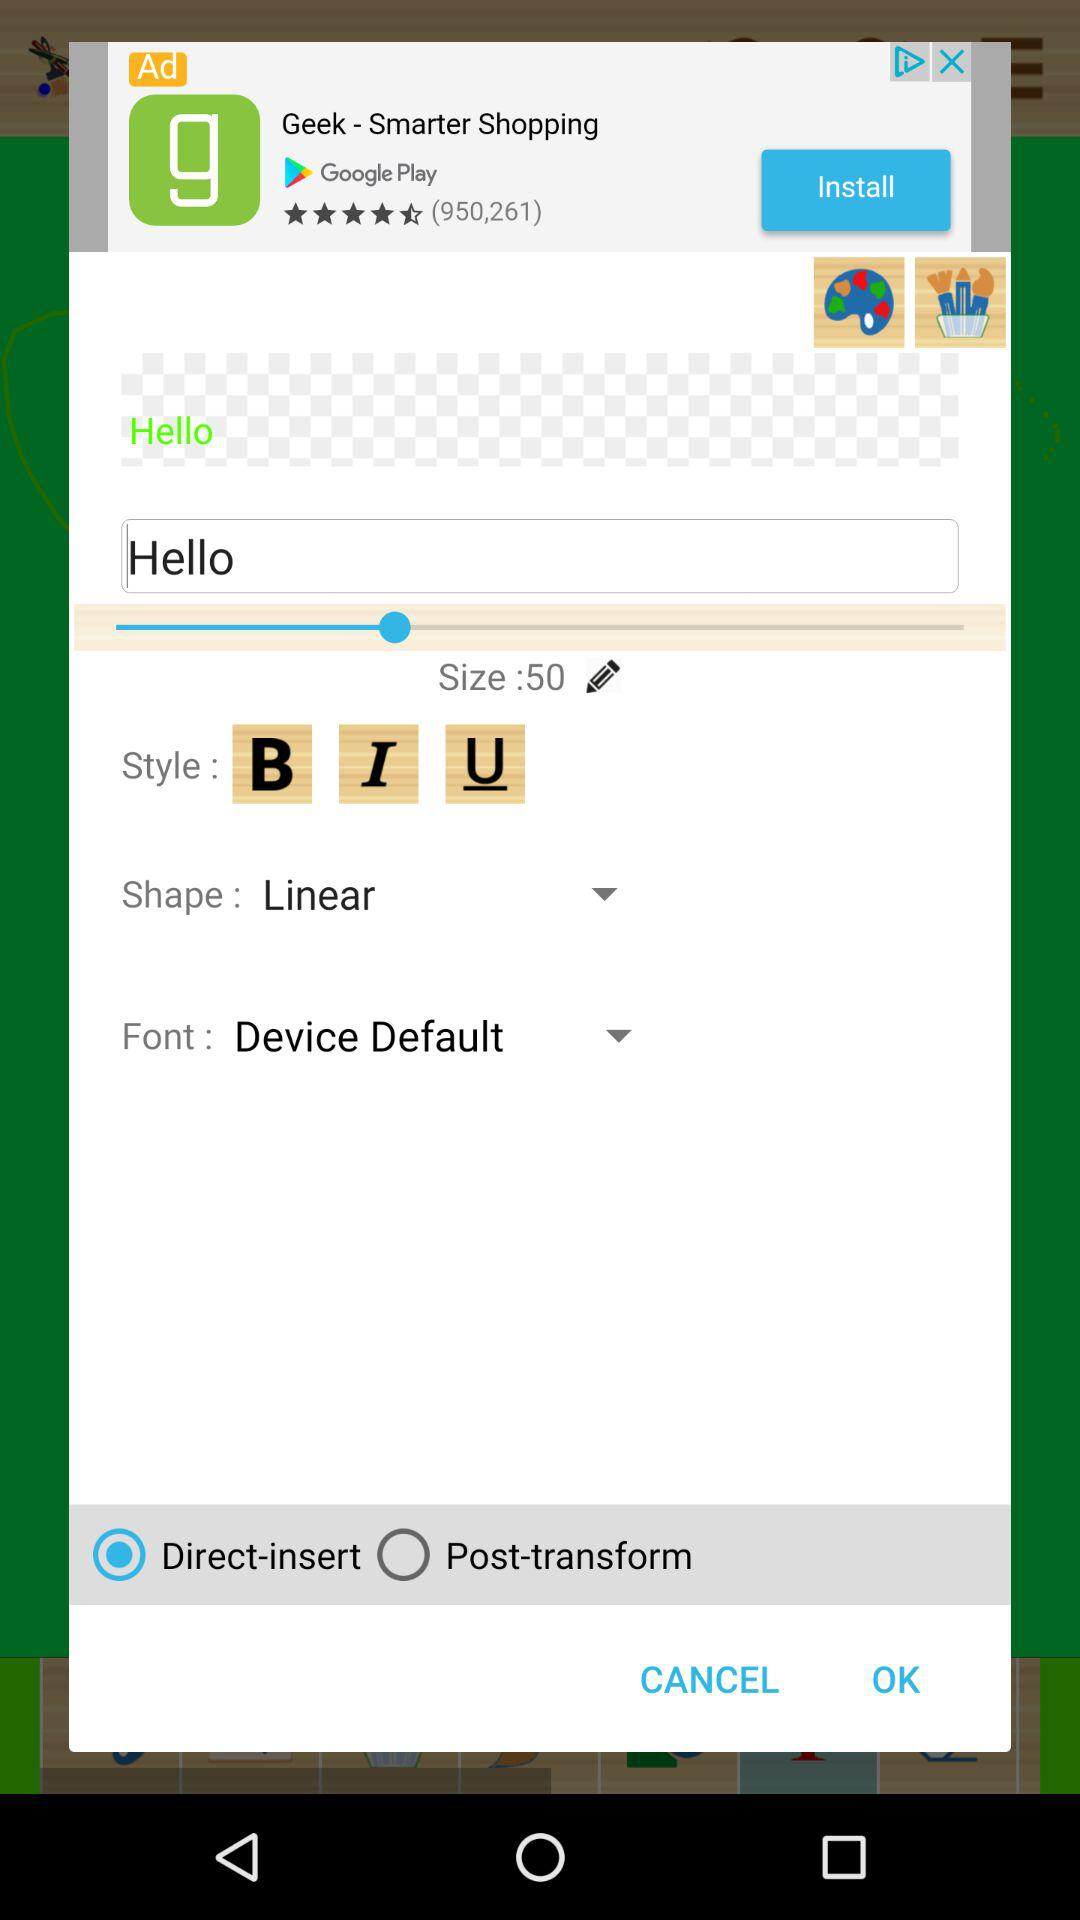What is the font for the text? The font for the text is "Device Default". 